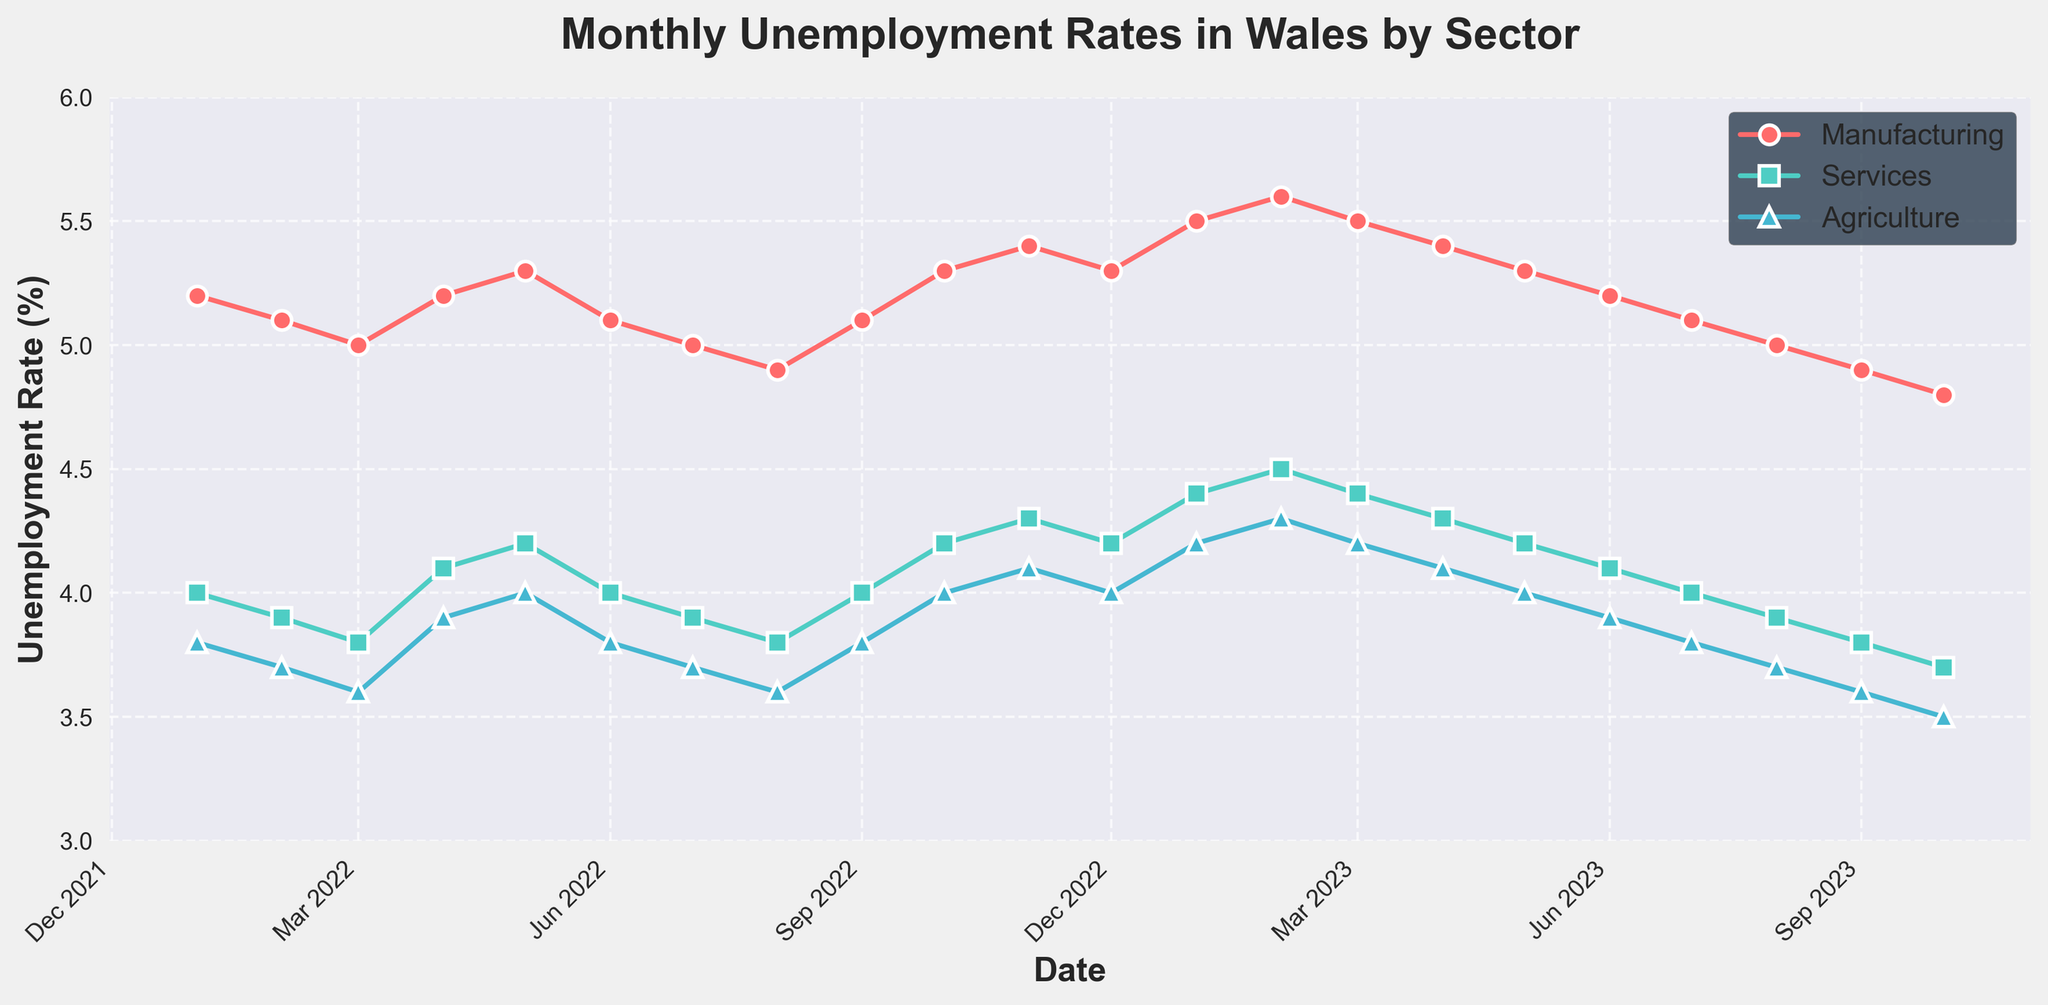What's the title of the figure? The title of the figure is displayed at the top of the plot in bold. It provides an overview of what the figure is about. Here, the title reads "Monthly Unemployment Rates in Wales by Sector".
Answer: Monthly Unemployment Rates in Wales by Sector What is the unemployment rate in the Services sector in March 2023? Locate the Services sector line (in blue with square markers) on the plot. Then find the data point corresponding to March 2023 on the x-axis and read the y-value.
Answer: 4.4% Which sector experienced the highest unemployment rate in January 2023? For January 2023, look at the data points for Manufacturing (red circles), Services (blue squares), and Agriculture (green triangles). Identify the sector with the highest y-value.
Answer: Manufacturing Between which months did the Agriculture sector's unemployment rate show a continuous decrease? Trace the green triangle markers for the Agriculture sector on the plot. Look for a sequence of months where each subsequent data point is lower than the previous one.
Answer: July 2023 to October 2023 On which dates did the Manufacturing sector have an unemployment rate equal to 5.3%? Follow the red circle markers for Manufacturing. Identify the points that align with the 5.3% mark on the y-axis and note their corresponding dates on the x-axis.
Answer: May 2022, October 2022, December 2022, May 2023 How does the unemployment rate in the Services sector in October 2023 compare to January 2022? Find and compare the y-values for the blue square markers in October 2023 and January 2022 to determine if it's higher, lower, or the same.
Answer: Lower What was the overall trend in the Manufacturing sector's unemployment rate from January 2022 to October 2023? Observe the red circle markers from the start (January 2022) to the end (October 2023) and determine if the general direction was increasing, decreasing, or fluctuating.
Answer: Decreasing Which sector had the least variability in unemployment rates over the period shown? Compare the spreads of the red, blue, and green lines: note which sector's line has the least fluctuation (smallest range of y-values).
Answer: Agriculture What is the average unemployment rate in the Agriculture sector for the year 2022? Look at the green triangle markers for 2022. Sum their y-values and divide by the number of months (12) to get the average.
Answer: (3.8 + 3.7 + 3.6 + 3.9 + 4.0 + 3.8 + 3.7 + 3.6 + 3.8 + 4.0 + 4.1 + 4.0) / 12 = 3.8333% By how much did the Services sector unemployment rate change from May 2023 to October 2023? Locate May 2023 and October 2023 blue square markers. Subtract the y-value of October 2023 from May 2023 to get the change.
Answer: 4.2% - 3.7% = -0.5% 